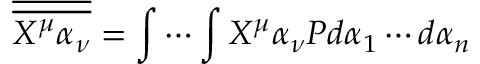Convert formula to latex. <formula><loc_0><loc_0><loc_500><loc_500>{ \overline { { \overline { { X ^ { \mu } \alpha _ { \nu } } } } } } = \int \cdots \int X ^ { \mu } \alpha _ { \nu } P d \alpha _ { 1 } \cdots d \alpha _ { n }</formula> 